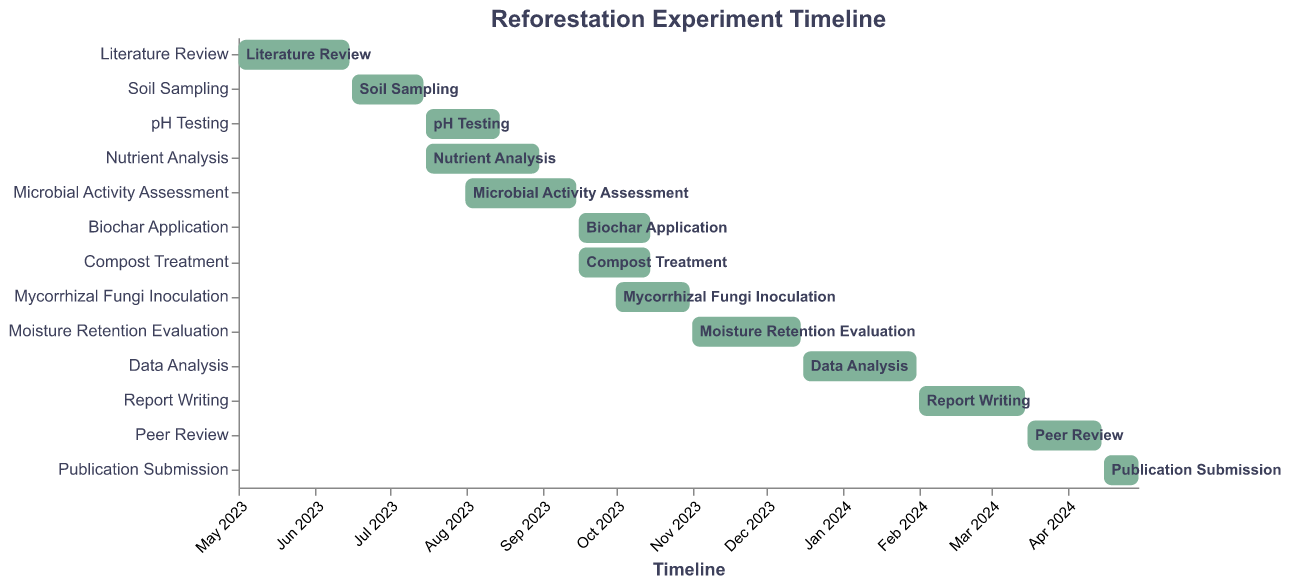What is the title of the Gantt Chart? The title of the chart is usually placed at the top and is larger than other text. In this case, it reads "Reforestation Experiment Timeline"
Answer: Reforestation Experiment Timeline What are the start and end dates for the Literature Review? The start and end dates for each task are represented by the left and right boundaries of the bars. For the Literature Review, these dates fall from 2023-05-01 to 2023-06-15
Answer: May 1, 2023 to June 15, 2023 What task starts immediately after the Soil Sampling ends? The Soil Sampling task ends on 2023-07-15. The next task to start is pH Testing, which begins on 2023-07-16
Answer: pH Testing Which tasks overlap and occur during the same time frame in September 2023? Tasks that overlap have bars extended between the same dates. In September 2023, Biochar Application, Compost Treatment, and Microbial Activity Assessment overlap
Answer: Biochar Application, Compost Treatment, Microbial Activity Assessment How long does the Nutrient Analysis take compared to the pH Testing? The Nutrient Analysis starts on 2023-07-16 and ends on 2023-08-31, making it 47 days long. The pH Testing starts on 2023-07-16 and ends on 2023-08-15, making it 31 days long. Nutrient Analysis is longer by 16 days
Answer: Nutrient Analysis is 16 days longer What is the duration of the Peer Review phase? The Peer Review phase starts on 2024-03-16 and ends on 2024-04-15, lasting 30 days
Answer: 30 days Which task has the shortest duration and how many days does it last? By comparing the lengths of the bars, the shortest task is Publication Submission, which starts on 2024-04-16 and ends on 2024-04-30, lasting 15 days
Answer: Publication Submission, 15 days Which tasks are focused on data collection? The tasks related to data collection include Soil Sampling, pH Testing, Nutrient Analysis, and Microbial Activity Assessment, as inferred from the context of soil quality improvement
Answer: Soil Sampling, pH Testing, Nutrient Analysis, Microbial Activity Assessment How does the timeline for Mycorrhizal Fungi Inoculation compare to the timeline for Compost Treatment? Mycorrhizal Fungi Inoculation runs from 2023-10-01 to 2023-10-31, while Compost Treatment runs from 2023-09-16 to 2023-10-15. The Compost Treatment task ends before Mycorrhizal Fungi Inoculation ends
Answer: Compost Treatment ends before Mycorrhizal Fungi Inoculation When does the Moisture Retention Evaluation task end? The Moisture Retention Evaluation starts on 2023-11-01 and ends on 2023-12-15, so it ends on December 15, 2023
Answer: December 15, 2023 